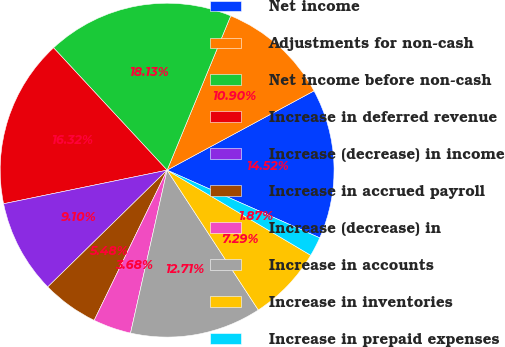Convert chart to OTSL. <chart><loc_0><loc_0><loc_500><loc_500><pie_chart><fcel>Net income<fcel>Adjustments for non-cash<fcel>Net income before non-cash<fcel>Increase in deferred revenue<fcel>Increase (decrease) in income<fcel>Increase in accrued payroll<fcel>Increase (decrease) in<fcel>Increase in accounts<fcel>Increase in inventories<fcel>Increase in prepaid expenses<nl><fcel>14.52%<fcel>10.9%<fcel>18.13%<fcel>16.32%<fcel>9.1%<fcel>5.48%<fcel>3.68%<fcel>12.71%<fcel>7.29%<fcel>1.87%<nl></chart> 